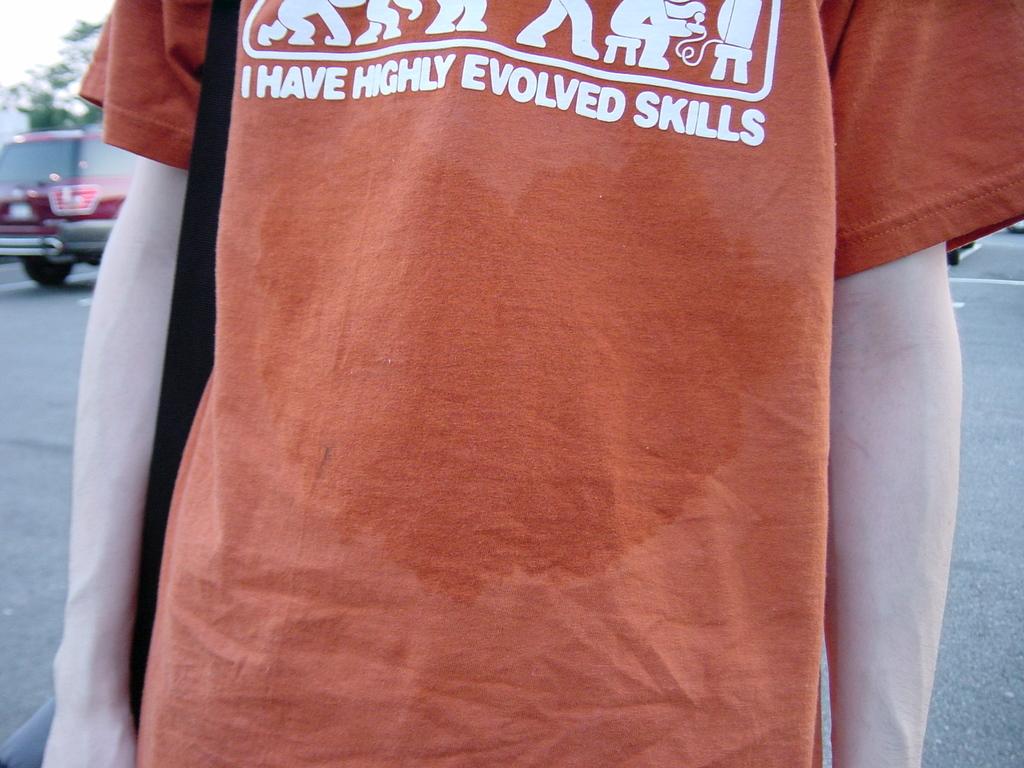What kind of skills do they have?
Provide a succinct answer. Highly evolved. 